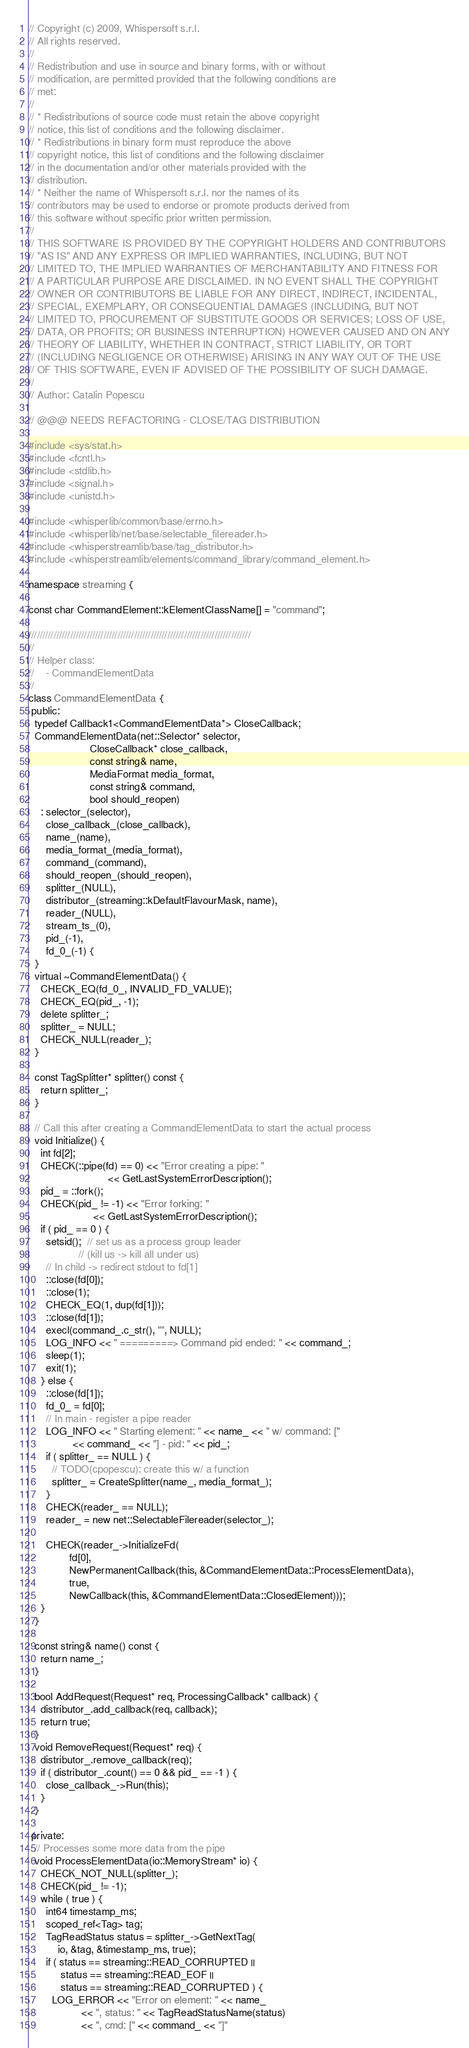Convert code to text. <code><loc_0><loc_0><loc_500><loc_500><_C++_>// Copyright (c) 2009, Whispersoft s.r.l.
// All rights reserved.
//
// Redistribution and use in source and binary forms, with or without
// modification, are permitted provided that the following conditions are
// met:
//
// * Redistributions of source code must retain the above copyright
// notice, this list of conditions and the following disclaimer.
// * Redistributions in binary form must reproduce the above
// copyright notice, this list of conditions and the following disclaimer
// in the documentation and/or other materials provided with the
// distribution.
// * Neither the name of Whispersoft s.r.l. nor the names of its
// contributors may be used to endorse or promote products derived from
// this software without specific prior written permission.
//
// THIS SOFTWARE IS PROVIDED BY THE COPYRIGHT HOLDERS AND CONTRIBUTORS
// "AS IS" AND ANY EXPRESS OR IMPLIED WARRANTIES, INCLUDING, BUT NOT
// LIMITED TO, THE IMPLIED WARRANTIES OF MERCHANTABILITY AND FITNESS FOR
// A PARTICULAR PURPOSE ARE DISCLAIMED. IN NO EVENT SHALL THE COPYRIGHT
// OWNER OR CONTRIBUTORS BE LIABLE FOR ANY DIRECT, INDIRECT, INCIDENTAL,
// SPECIAL, EXEMPLARY, OR CONSEQUENTIAL DAMAGES (INCLUDING, BUT NOT
// LIMITED TO, PROCUREMENT OF SUBSTITUTE GOODS OR SERVICES; LOSS OF USE,
// DATA, OR PROFITS; OR BUSINESS INTERRUPTION) HOWEVER CAUSED AND ON ANY
// THEORY OF LIABILITY, WHETHER IN CONTRACT, STRICT LIABILITY, OR TORT
// (INCLUDING NEGLIGENCE OR OTHERWISE) ARISING IN ANY WAY OUT OF THE USE
// OF THIS SOFTWARE, EVEN IF ADVISED OF THE POSSIBILITY OF SUCH DAMAGE.
//
// Author: Catalin Popescu

// @@@ NEEDS REFACTORING - CLOSE/TAG DISTRIBUTION

#include <sys/stat.h>
#include <fcntl.h>
#include <stdlib.h>
#include <signal.h>
#include <unistd.h>

#include <whisperlib/common/base/errno.h>
#include <whisperlib/net/base/selectable_filereader.h>
#include <whisperstreamlib/base/tag_distributor.h>
#include <whisperstreamlib/elements/command_library/command_element.h>

namespace streaming {

const char CommandElement::kElementClassName[] = "command";

////////////////////////////////////////////////////////////////////////////////
//
// Helper class:
//    - CommandElementData
//
class CommandElementData {
 public:
  typedef Callback1<CommandElementData*> CloseCallback;
  CommandElementData(net::Selector* selector,
                     CloseCallback* close_callback,
                     const string& name,
                     MediaFormat media_format,
                     const string& command,
                     bool should_reopen)
    : selector_(selector),
      close_callback_(close_callback),
      name_(name),
      media_format_(media_format),
      command_(command),
      should_reopen_(should_reopen),
      splitter_(NULL),
      distributor_(streaming::kDefaultFlavourMask, name),
      reader_(NULL),
      stream_ts_(0),
      pid_(-1),
      fd_0_(-1) {
  }
  virtual ~CommandElementData() {
    CHECK_EQ(fd_0_, INVALID_FD_VALUE);
    CHECK_EQ(pid_, -1);
    delete splitter_;
    splitter_ = NULL;
    CHECK_NULL(reader_);
  }

  const TagSplitter* splitter() const {
    return splitter_;
  }

  // Call this after creating a CommandElementData to start the actual process
  void Initialize() {
    int fd[2];
    CHECK(::pipe(fd) == 0) << "Error creating a pipe: "
                           << GetLastSystemErrorDescription();
    pid_ = ::fork();
    CHECK(pid_ != -1) << "Error forking: "
                      << GetLastSystemErrorDescription();
    if ( pid_ == 0 ) {
      setsid();  // set us as a process group leader
                 // (kill us -> kill all under us)
      // In child -> redirect stdout to fd[1]
      ::close(fd[0]);
      ::close(1);
      CHECK_EQ(1, dup(fd[1]));
      ::close(fd[1]);
      execl(command_.c_str(), "", NULL);
      LOG_INFO << " =========> Command pid ended: " << command_;
      sleep(1);
      exit(1);
    } else {
      ::close(fd[1]);
      fd_0_ = fd[0];
      // In main - register a pipe reader
      LOG_INFO << " Starting element: " << name_ << " w/ command: ["
               << command_ << "] - pid: " << pid_;
      if ( splitter_ == NULL ) {
        // TODO(cpopescu): create this w/ a function
        splitter_ = CreateSplitter(name_, media_format_);
      }
      CHECK(reader_ == NULL);
      reader_ = new net::SelectableFilereader(selector_);

      CHECK(reader_->InitializeFd(
              fd[0],
              NewPermanentCallback(this, &CommandElementData::ProcessElementData),
              true,
              NewCallback(this, &CommandElementData::ClosedElement)));
    }
  }

  const string& name() const {
    return name_;
  }

  bool AddRequest(Request* req, ProcessingCallback* callback) {
    distributor_.add_callback(req, callback);
    return true;
  }
  void RemoveRequest(Request* req) {
    distributor_.remove_callback(req);
    if ( distributor_.count() == 0 && pid_ == -1 ) {
      close_callback_->Run(this);
    }
  }

 private:
  // Processes some more data from the pipe
  void ProcessElementData(io::MemoryStream* io) {
    CHECK_NOT_NULL(splitter_);
    CHECK(pid_ != -1);
    while ( true ) {
      int64 timestamp_ms;
      scoped_ref<Tag> tag;
      TagReadStatus status = splitter_->GetNextTag(
          io, &tag, &timestamp_ms, true);
      if ( status == streaming::READ_CORRUPTED ||
           status == streaming::READ_EOF ||
           status == streaming::READ_CORRUPTED ) {
        LOG_ERROR << "Error on element: " << name_
                  << ", status: " << TagReadStatusName(status)
                  << ", cmd: [" << command_ << "]"</code> 